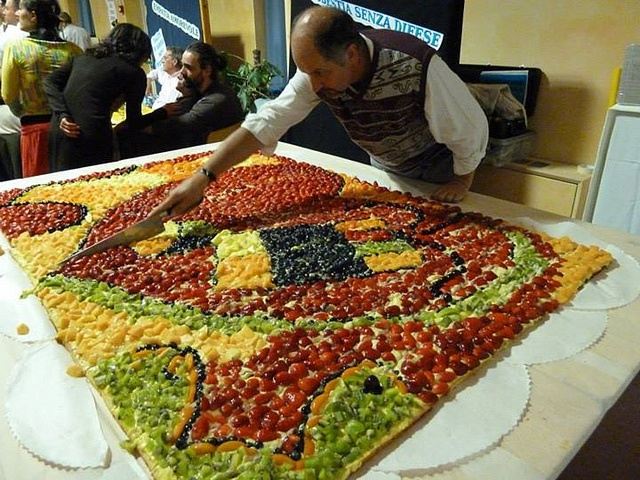Describe the objects in this image and their specific colors. I can see dining table in lightgray, maroon, beige, olive, and brown tones, pizza in lightgray, maroon, olive, brown, and black tones, people in lightgray, black, maroon, and gray tones, people in lightgray, black, darkgreen, maroon, and gray tones, and people in lightgray, black, olive, maroon, and brown tones in this image. 